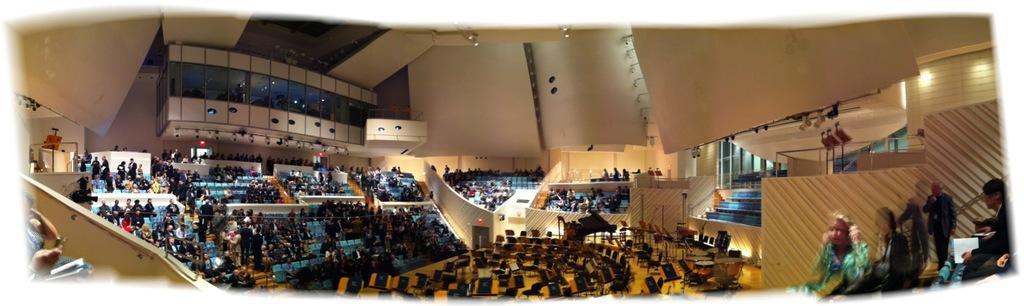Describe this image in one or two sentences. In the picture I can see people among them some are standing and some are sitting on chairs. This is an inside view of a building. I can also see some empty chairs, walls and lights. I can also see fence and some other objects on the floor. 